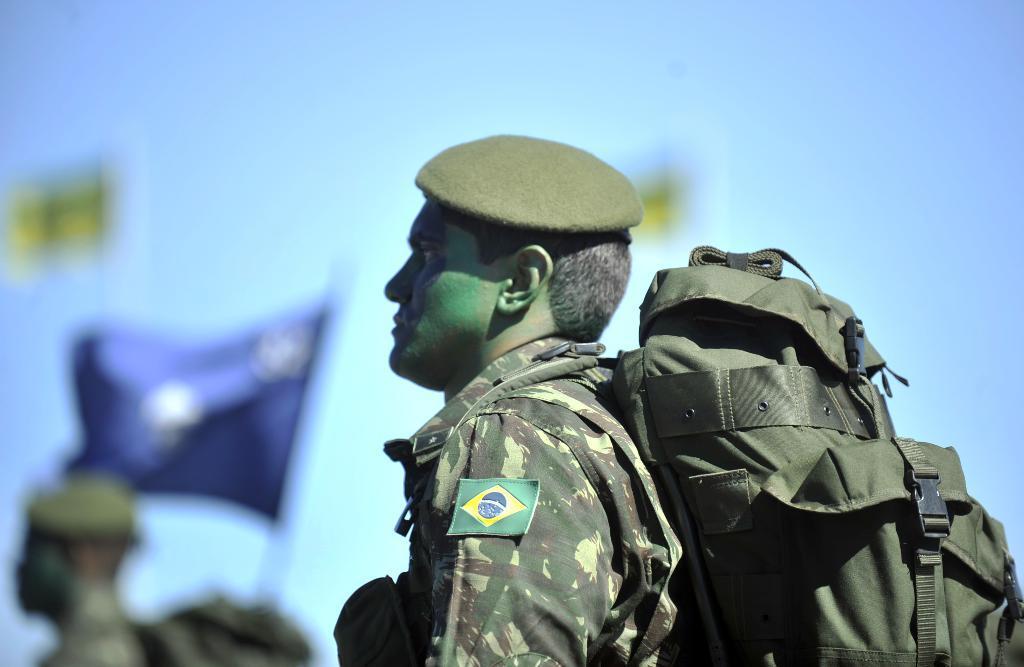Can you describe this image briefly? In front of the image there is man with uniform and a cap on the head. He is standing and he wore a bag. Behind him there is a blur background with flags and a man. And there is sky in the background. 